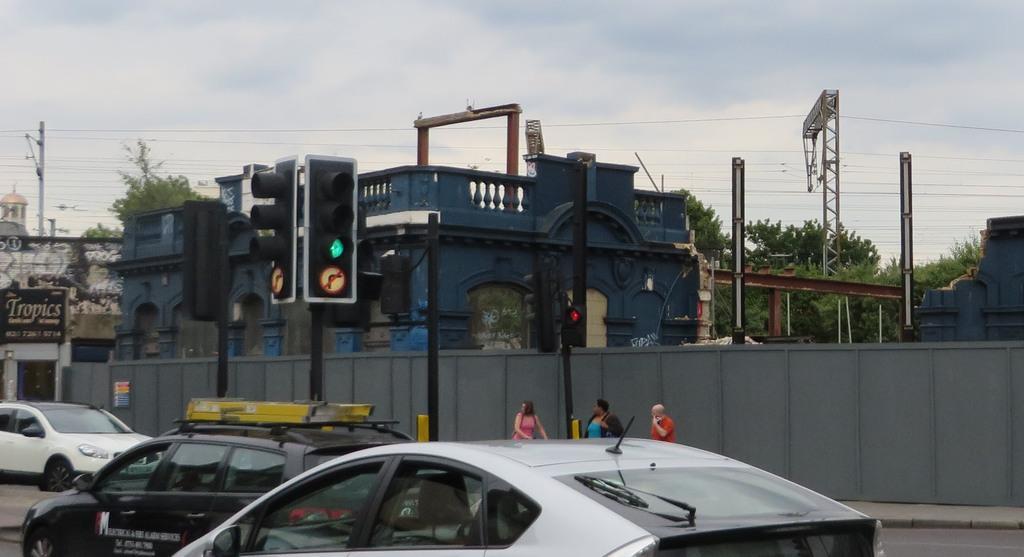In one or two sentences, can you explain what this image depicts? In the background we can see the sky, a dome is visible, trees, poles, transmission wires, building, traffic signals, tower, compound wall. In this picture we can see the compound wall, people, boards. We can see the vehicles on the road. 